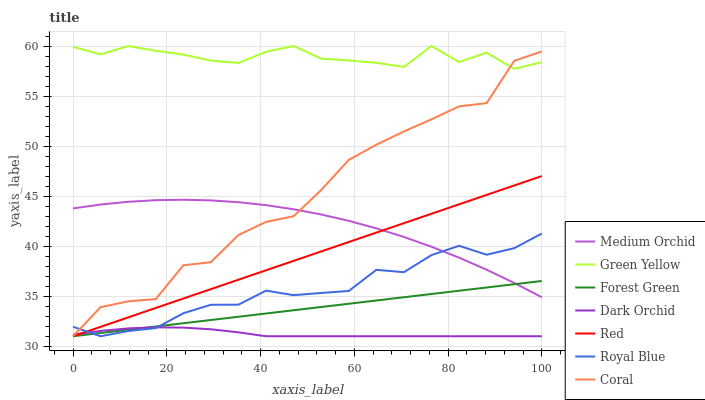Does Dark Orchid have the minimum area under the curve?
Answer yes or no. Yes. Does Green Yellow have the maximum area under the curve?
Answer yes or no. Yes. Does Medium Orchid have the minimum area under the curve?
Answer yes or no. No. Does Medium Orchid have the maximum area under the curve?
Answer yes or no. No. Is Forest Green the smoothest?
Answer yes or no. Yes. Is Coral the roughest?
Answer yes or no. Yes. Is Medium Orchid the smoothest?
Answer yes or no. No. Is Medium Orchid the roughest?
Answer yes or no. No. Does Coral have the lowest value?
Answer yes or no. Yes. Does Medium Orchid have the lowest value?
Answer yes or no. No. Does Green Yellow have the highest value?
Answer yes or no. Yes. Does Medium Orchid have the highest value?
Answer yes or no. No. Is Red less than Green Yellow?
Answer yes or no. Yes. Is Medium Orchid greater than Dark Orchid?
Answer yes or no. Yes. Does Coral intersect Forest Green?
Answer yes or no. Yes. Is Coral less than Forest Green?
Answer yes or no. No. Is Coral greater than Forest Green?
Answer yes or no. No. Does Red intersect Green Yellow?
Answer yes or no. No. 